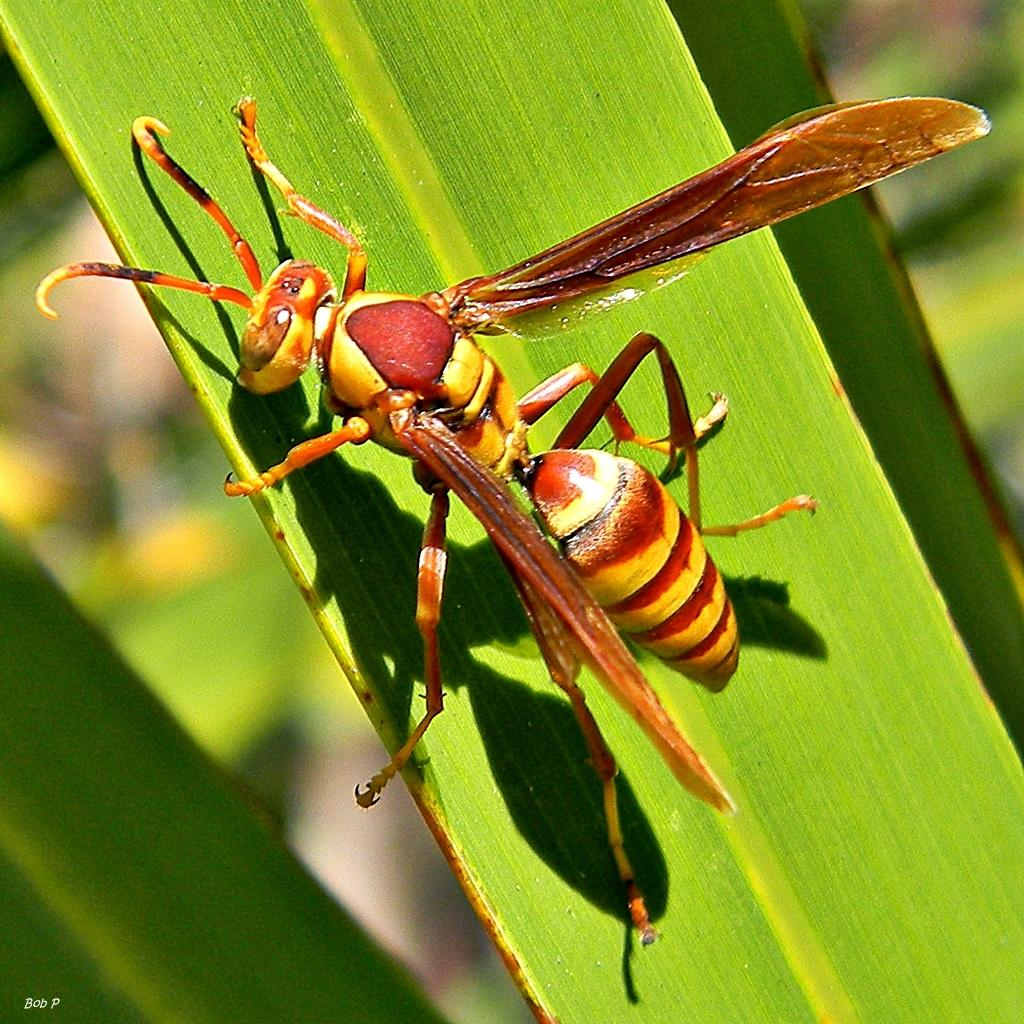What type of insect is in the picture? There is a brown flying ant in the picture. Where is the flying ant located? The flying ant is sitting on a green leaf. Can you describe the background of the image? The background of the image is blurred. How many girls are present in the image? There are no girls present in the image; it features a brown flying ant on a green leaf. What is the level of disgust one might feel when looking at the image? The level of disgust one might feel when looking at the image is subjective and cannot be determined from the image itself. 